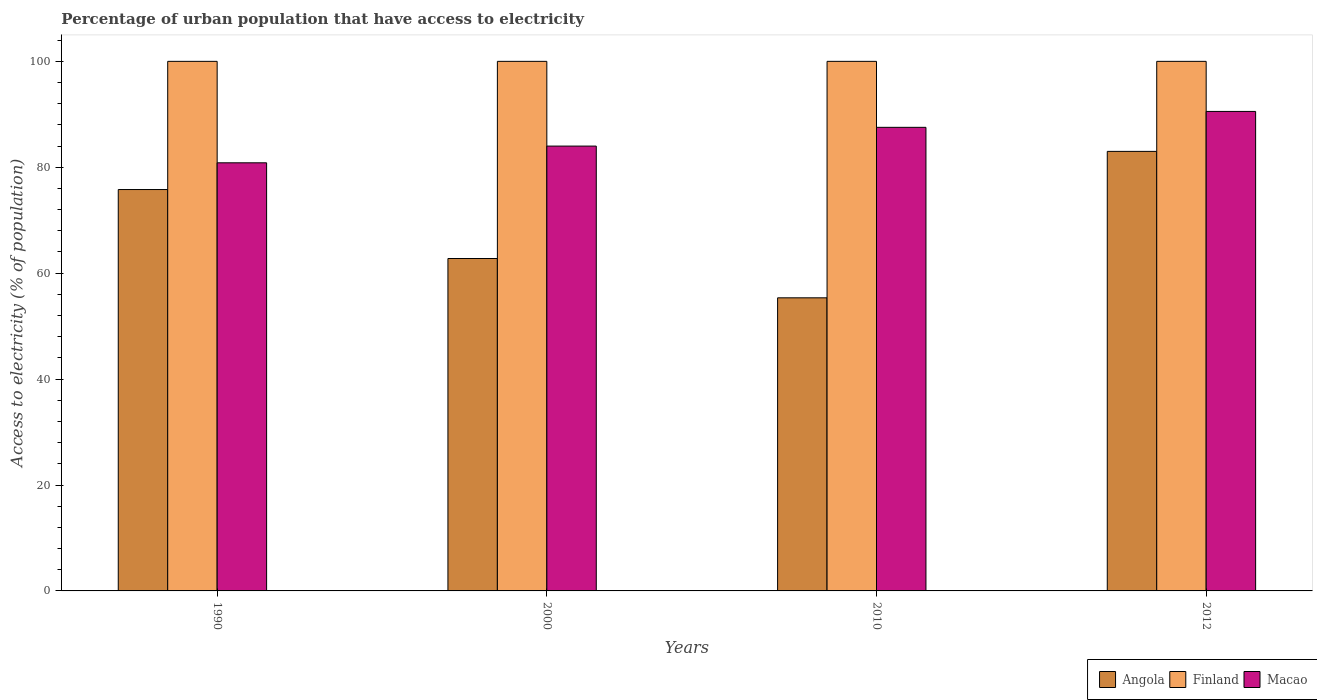How many different coloured bars are there?
Give a very brief answer. 3. Are the number of bars on each tick of the X-axis equal?
Offer a very short reply. Yes. How many bars are there on the 2nd tick from the right?
Provide a short and direct response. 3. What is the percentage of urban population that have access to electricity in Macao in 2010?
Your answer should be very brief. 87.54. Across all years, what is the maximum percentage of urban population that have access to electricity in Angola?
Make the answer very short. 83. Across all years, what is the minimum percentage of urban population that have access to electricity in Finland?
Make the answer very short. 100. What is the total percentage of urban population that have access to electricity in Finland in the graph?
Your answer should be very brief. 400. What is the difference between the percentage of urban population that have access to electricity in Angola in 1990 and that in 2012?
Your response must be concise. -7.21. What is the difference between the percentage of urban population that have access to electricity in Macao in 2010 and the percentage of urban population that have access to electricity in Angola in 1990?
Offer a very short reply. 11.75. What is the average percentage of urban population that have access to electricity in Macao per year?
Your answer should be very brief. 85.73. In the year 1990, what is the difference between the percentage of urban population that have access to electricity in Finland and percentage of urban population that have access to electricity in Angola?
Keep it short and to the point. 24.21. In how many years, is the percentage of urban population that have access to electricity in Macao greater than 80 %?
Provide a short and direct response. 4. Is the difference between the percentage of urban population that have access to electricity in Finland in 2000 and 2012 greater than the difference between the percentage of urban population that have access to electricity in Angola in 2000 and 2012?
Offer a very short reply. Yes. What is the difference between the highest and the second highest percentage of urban population that have access to electricity in Finland?
Offer a very short reply. 0. What is the difference between the highest and the lowest percentage of urban population that have access to electricity in Finland?
Your answer should be very brief. 0. In how many years, is the percentage of urban population that have access to electricity in Finland greater than the average percentage of urban population that have access to electricity in Finland taken over all years?
Ensure brevity in your answer.  0. What does the 1st bar from the left in 1990 represents?
Make the answer very short. Angola. What does the 2nd bar from the right in 2010 represents?
Offer a very short reply. Finland. Is it the case that in every year, the sum of the percentage of urban population that have access to electricity in Angola and percentage of urban population that have access to electricity in Macao is greater than the percentage of urban population that have access to electricity in Finland?
Make the answer very short. Yes. How many bars are there?
Your response must be concise. 12. Are all the bars in the graph horizontal?
Give a very brief answer. No. What is the difference between two consecutive major ticks on the Y-axis?
Make the answer very short. 20. Are the values on the major ticks of Y-axis written in scientific E-notation?
Make the answer very short. No. Does the graph contain grids?
Provide a short and direct response. No. How many legend labels are there?
Your answer should be compact. 3. What is the title of the graph?
Provide a succinct answer. Percentage of urban population that have access to electricity. Does "Macedonia" appear as one of the legend labels in the graph?
Provide a succinct answer. No. What is the label or title of the Y-axis?
Give a very brief answer. Access to electricity (% of population). What is the Access to electricity (% of population) in Angola in 1990?
Your response must be concise. 75.79. What is the Access to electricity (% of population) of Macao in 1990?
Your answer should be very brief. 80.84. What is the Access to electricity (% of population) in Angola in 2000?
Your answer should be compact. 62.77. What is the Access to electricity (% of population) in Macao in 2000?
Your answer should be compact. 84. What is the Access to electricity (% of population) of Angola in 2010?
Make the answer very short. 55.35. What is the Access to electricity (% of population) in Macao in 2010?
Provide a short and direct response. 87.54. What is the Access to electricity (% of population) of Angola in 2012?
Provide a short and direct response. 83. What is the Access to electricity (% of population) of Macao in 2012?
Make the answer very short. 90.54. Across all years, what is the maximum Access to electricity (% of population) in Angola?
Offer a very short reply. 83. Across all years, what is the maximum Access to electricity (% of population) in Finland?
Keep it short and to the point. 100. Across all years, what is the maximum Access to electricity (% of population) of Macao?
Make the answer very short. 90.54. Across all years, what is the minimum Access to electricity (% of population) of Angola?
Your answer should be compact. 55.35. Across all years, what is the minimum Access to electricity (% of population) in Finland?
Offer a terse response. 100. Across all years, what is the minimum Access to electricity (% of population) of Macao?
Give a very brief answer. 80.84. What is the total Access to electricity (% of population) in Angola in the graph?
Provide a short and direct response. 276.91. What is the total Access to electricity (% of population) in Macao in the graph?
Give a very brief answer. 342.92. What is the difference between the Access to electricity (% of population) of Angola in 1990 and that in 2000?
Make the answer very short. 13.02. What is the difference between the Access to electricity (% of population) of Finland in 1990 and that in 2000?
Offer a terse response. 0. What is the difference between the Access to electricity (% of population) in Macao in 1990 and that in 2000?
Give a very brief answer. -3.16. What is the difference between the Access to electricity (% of population) of Angola in 1990 and that in 2010?
Provide a succinct answer. 20.45. What is the difference between the Access to electricity (% of population) of Macao in 1990 and that in 2010?
Make the answer very short. -6.7. What is the difference between the Access to electricity (% of population) in Angola in 1990 and that in 2012?
Ensure brevity in your answer.  -7.21. What is the difference between the Access to electricity (% of population) of Finland in 1990 and that in 2012?
Provide a succinct answer. 0. What is the difference between the Access to electricity (% of population) in Macao in 1990 and that in 2012?
Ensure brevity in your answer.  -9.7. What is the difference between the Access to electricity (% of population) in Angola in 2000 and that in 2010?
Your answer should be compact. 7.42. What is the difference between the Access to electricity (% of population) in Finland in 2000 and that in 2010?
Give a very brief answer. 0. What is the difference between the Access to electricity (% of population) in Macao in 2000 and that in 2010?
Provide a succinct answer. -3.54. What is the difference between the Access to electricity (% of population) in Angola in 2000 and that in 2012?
Make the answer very short. -20.23. What is the difference between the Access to electricity (% of population) of Macao in 2000 and that in 2012?
Offer a terse response. -6.54. What is the difference between the Access to electricity (% of population) in Angola in 2010 and that in 2012?
Give a very brief answer. -27.65. What is the difference between the Access to electricity (% of population) in Finland in 2010 and that in 2012?
Keep it short and to the point. 0. What is the difference between the Access to electricity (% of population) in Macao in 2010 and that in 2012?
Ensure brevity in your answer.  -3. What is the difference between the Access to electricity (% of population) of Angola in 1990 and the Access to electricity (% of population) of Finland in 2000?
Offer a very short reply. -24.21. What is the difference between the Access to electricity (% of population) in Angola in 1990 and the Access to electricity (% of population) in Macao in 2000?
Offer a terse response. -8.21. What is the difference between the Access to electricity (% of population) of Finland in 1990 and the Access to electricity (% of population) of Macao in 2000?
Provide a short and direct response. 16. What is the difference between the Access to electricity (% of population) in Angola in 1990 and the Access to electricity (% of population) in Finland in 2010?
Provide a short and direct response. -24.21. What is the difference between the Access to electricity (% of population) in Angola in 1990 and the Access to electricity (% of population) in Macao in 2010?
Your answer should be compact. -11.75. What is the difference between the Access to electricity (% of population) of Finland in 1990 and the Access to electricity (% of population) of Macao in 2010?
Give a very brief answer. 12.46. What is the difference between the Access to electricity (% of population) of Angola in 1990 and the Access to electricity (% of population) of Finland in 2012?
Offer a very short reply. -24.21. What is the difference between the Access to electricity (% of population) in Angola in 1990 and the Access to electricity (% of population) in Macao in 2012?
Offer a terse response. -14.75. What is the difference between the Access to electricity (% of population) in Finland in 1990 and the Access to electricity (% of population) in Macao in 2012?
Your answer should be very brief. 9.46. What is the difference between the Access to electricity (% of population) of Angola in 2000 and the Access to electricity (% of population) of Finland in 2010?
Offer a terse response. -37.23. What is the difference between the Access to electricity (% of population) of Angola in 2000 and the Access to electricity (% of population) of Macao in 2010?
Give a very brief answer. -24.77. What is the difference between the Access to electricity (% of population) of Finland in 2000 and the Access to electricity (% of population) of Macao in 2010?
Provide a succinct answer. 12.46. What is the difference between the Access to electricity (% of population) of Angola in 2000 and the Access to electricity (% of population) of Finland in 2012?
Your response must be concise. -37.23. What is the difference between the Access to electricity (% of population) of Angola in 2000 and the Access to electricity (% of population) of Macao in 2012?
Give a very brief answer. -27.77. What is the difference between the Access to electricity (% of population) in Finland in 2000 and the Access to electricity (% of population) in Macao in 2012?
Offer a terse response. 9.46. What is the difference between the Access to electricity (% of population) of Angola in 2010 and the Access to electricity (% of population) of Finland in 2012?
Keep it short and to the point. -44.65. What is the difference between the Access to electricity (% of population) of Angola in 2010 and the Access to electricity (% of population) of Macao in 2012?
Provide a succinct answer. -35.2. What is the difference between the Access to electricity (% of population) in Finland in 2010 and the Access to electricity (% of population) in Macao in 2012?
Provide a short and direct response. 9.46. What is the average Access to electricity (% of population) in Angola per year?
Give a very brief answer. 69.23. What is the average Access to electricity (% of population) of Finland per year?
Give a very brief answer. 100. What is the average Access to electricity (% of population) in Macao per year?
Your response must be concise. 85.73. In the year 1990, what is the difference between the Access to electricity (% of population) in Angola and Access to electricity (% of population) in Finland?
Keep it short and to the point. -24.21. In the year 1990, what is the difference between the Access to electricity (% of population) of Angola and Access to electricity (% of population) of Macao?
Offer a terse response. -5.05. In the year 1990, what is the difference between the Access to electricity (% of population) in Finland and Access to electricity (% of population) in Macao?
Your response must be concise. 19.16. In the year 2000, what is the difference between the Access to electricity (% of population) in Angola and Access to electricity (% of population) in Finland?
Ensure brevity in your answer.  -37.23. In the year 2000, what is the difference between the Access to electricity (% of population) in Angola and Access to electricity (% of population) in Macao?
Your answer should be very brief. -21.23. In the year 2010, what is the difference between the Access to electricity (% of population) of Angola and Access to electricity (% of population) of Finland?
Your answer should be compact. -44.65. In the year 2010, what is the difference between the Access to electricity (% of population) in Angola and Access to electricity (% of population) in Macao?
Give a very brief answer. -32.19. In the year 2010, what is the difference between the Access to electricity (% of population) in Finland and Access to electricity (% of population) in Macao?
Your answer should be compact. 12.46. In the year 2012, what is the difference between the Access to electricity (% of population) in Angola and Access to electricity (% of population) in Finland?
Provide a succinct answer. -17. In the year 2012, what is the difference between the Access to electricity (% of population) of Angola and Access to electricity (% of population) of Macao?
Your answer should be very brief. -7.54. In the year 2012, what is the difference between the Access to electricity (% of population) of Finland and Access to electricity (% of population) of Macao?
Provide a succinct answer. 9.46. What is the ratio of the Access to electricity (% of population) in Angola in 1990 to that in 2000?
Give a very brief answer. 1.21. What is the ratio of the Access to electricity (% of population) of Finland in 1990 to that in 2000?
Offer a very short reply. 1. What is the ratio of the Access to electricity (% of population) in Macao in 1990 to that in 2000?
Your answer should be very brief. 0.96. What is the ratio of the Access to electricity (% of population) in Angola in 1990 to that in 2010?
Your answer should be compact. 1.37. What is the ratio of the Access to electricity (% of population) in Finland in 1990 to that in 2010?
Ensure brevity in your answer.  1. What is the ratio of the Access to electricity (% of population) in Macao in 1990 to that in 2010?
Give a very brief answer. 0.92. What is the ratio of the Access to electricity (% of population) in Angola in 1990 to that in 2012?
Offer a very short reply. 0.91. What is the ratio of the Access to electricity (% of population) of Finland in 1990 to that in 2012?
Keep it short and to the point. 1. What is the ratio of the Access to electricity (% of population) of Macao in 1990 to that in 2012?
Your response must be concise. 0.89. What is the ratio of the Access to electricity (% of population) of Angola in 2000 to that in 2010?
Your answer should be very brief. 1.13. What is the ratio of the Access to electricity (% of population) in Macao in 2000 to that in 2010?
Make the answer very short. 0.96. What is the ratio of the Access to electricity (% of population) in Angola in 2000 to that in 2012?
Provide a succinct answer. 0.76. What is the ratio of the Access to electricity (% of population) in Finland in 2000 to that in 2012?
Keep it short and to the point. 1. What is the ratio of the Access to electricity (% of population) of Macao in 2000 to that in 2012?
Your response must be concise. 0.93. What is the ratio of the Access to electricity (% of population) of Angola in 2010 to that in 2012?
Your answer should be very brief. 0.67. What is the ratio of the Access to electricity (% of population) of Finland in 2010 to that in 2012?
Offer a terse response. 1. What is the ratio of the Access to electricity (% of population) of Macao in 2010 to that in 2012?
Your answer should be very brief. 0.97. What is the difference between the highest and the second highest Access to electricity (% of population) of Angola?
Offer a very short reply. 7.21. What is the difference between the highest and the second highest Access to electricity (% of population) of Finland?
Provide a succinct answer. 0. What is the difference between the highest and the second highest Access to electricity (% of population) in Macao?
Give a very brief answer. 3. What is the difference between the highest and the lowest Access to electricity (% of population) in Angola?
Keep it short and to the point. 27.65. What is the difference between the highest and the lowest Access to electricity (% of population) in Finland?
Your response must be concise. 0. What is the difference between the highest and the lowest Access to electricity (% of population) in Macao?
Keep it short and to the point. 9.7. 